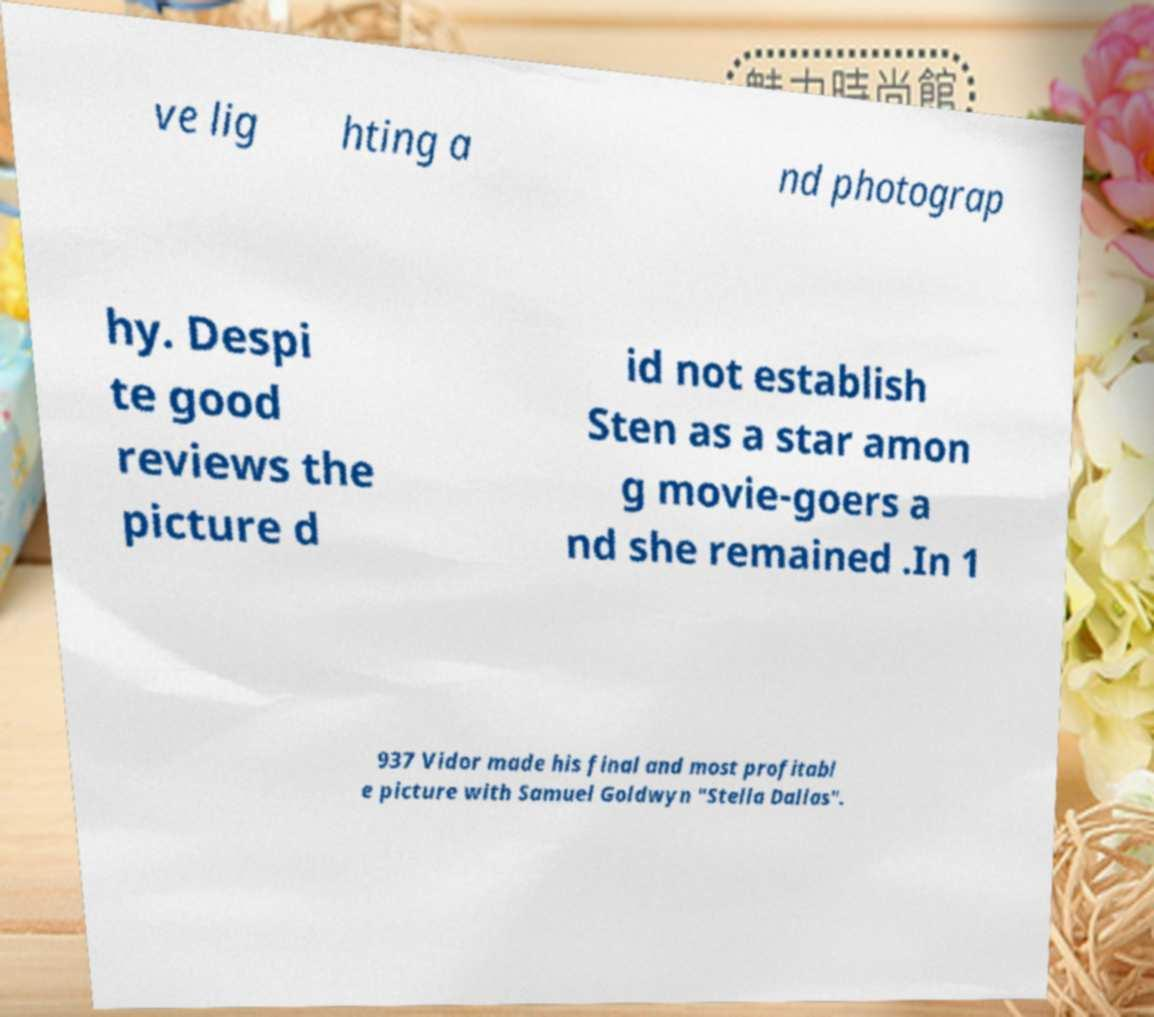Can you read and provide the text displayed in the image?This photo seems to have some interesting text. Can you extract and type it out for me? ve lig hting a nd photograp hy. Despi te good reviews the picture d id not establish Sten as a star amon g movie-goers a nd she remained .In 1 937 Vidor made his final and most profitabl e picture with Samuel Goldwyn "Stella Dallas". 